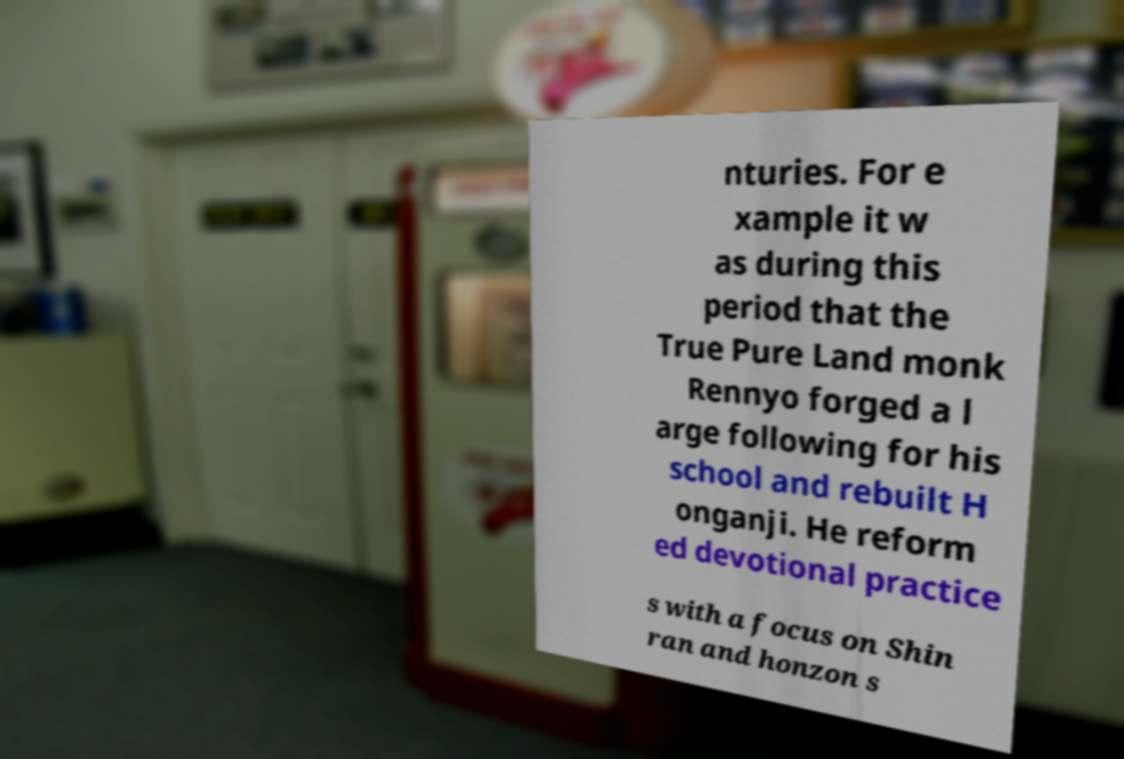What messages or text are displayed in this image? I need them in a readable, typed format. nturies. For e xample it w as during this period that the True Pure Land monk Rennyo forged a l arge following for his school and rebuilt H onganji. He reform ed devotional practice s with a focus on Shin ran and honzon s 